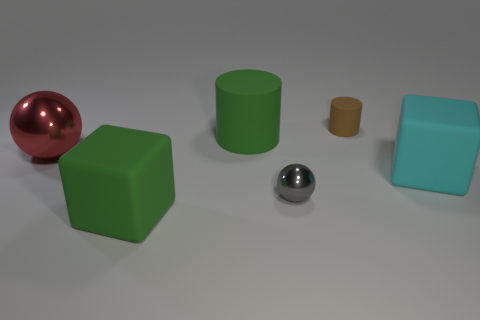Does the ball in front of the big shiny thing have the same size as the thing that is in front of the tiny gray sphere?
Keep it short and to the point. No. What number of things are either metal things that are on the right side of the large red metal thing or small brown rubber objects that are behind the green matte cube?
Give a very brief answer. 2. Are the gray ball and the sphere that is behind the gray object made of the same material?
Your response must be concise. Yes. There is a large object that is both on the left side of the big cylinder and on the right side of the large metallic object; what is its shape?
Provide a succinct answer. Cube. How many other objects are there of the same color as the big metal ball?
Your answer should be compact. 0. What is the shape of the brown object?
Offer a very short reply. Cylinder. There is a metallic ball on the left side of the ball in front of the red metallic sphere; what is its color?
Provide a short and direct response. Red. There is a large cylinder; is it the same color as the rubber block that is in front of the cyan rubber cube?
Your answer should be very brief. Yes. What is the thing that is both behind the large red object and on the left side of the tiny gray thing made of?
Give a very brief answer. Rubber. Is there a green matte cube that has the same size as the cyan matte object?
Ensure brevity in your answer.  Yes. 